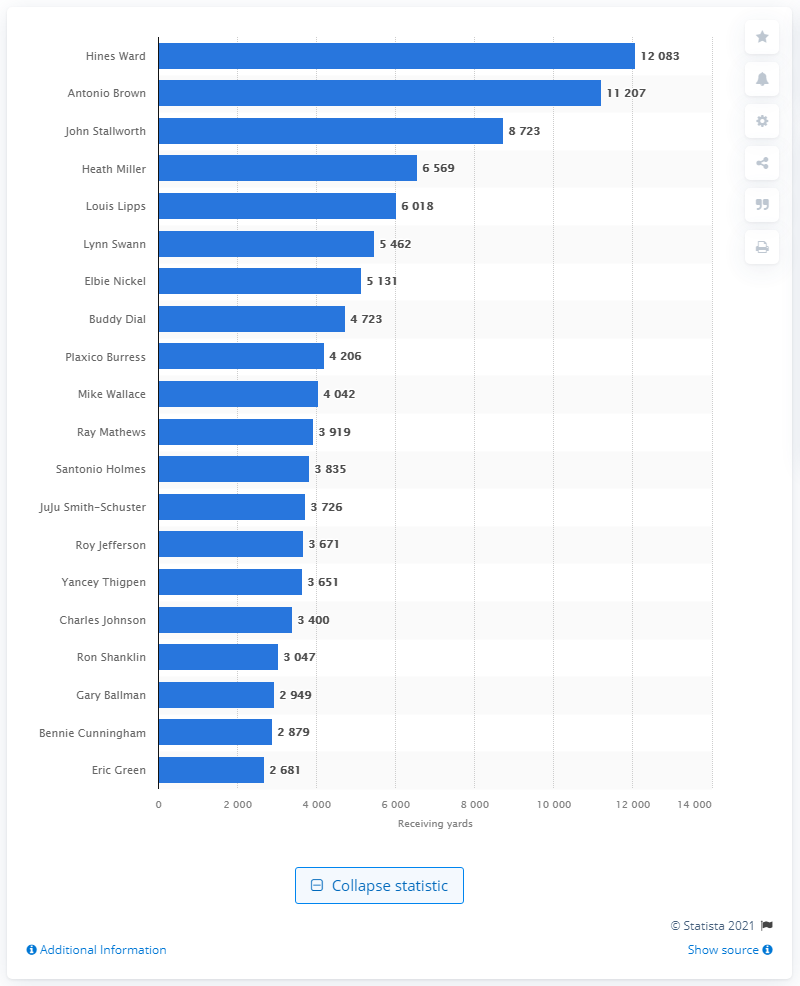Specify some key components in this picture. Hines Ward is the career receiving leader of the Pittsburgh Steelers. 